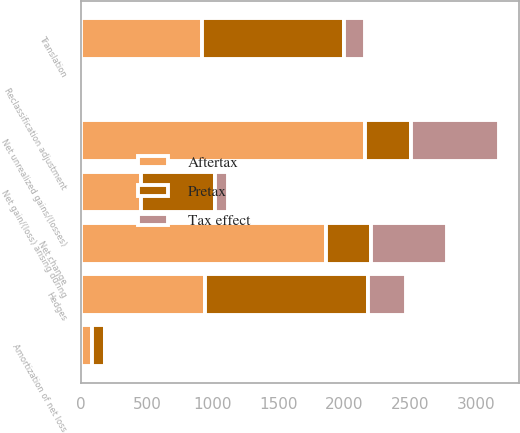Convert chart to OTSL. <chart><loc_0><loc_0><loc_500><loc_500><stacked_bar_chart><ecel><fcel>Net unrealized gains/(losses)<fcel>Reclassification adjustment<fcel>Net change<fcel>Translation<fcel>Hedges<fcel>Net gain/(loss) arising during<fcel>Amortization of net loss<nl><fcel>Pretax<fcel>348.5<fcel>18<fcel>348.5<fcel>1078<fcel>1236<fcel>558<fcel>103<nl><fcel>Tax effect<fcel>665<fcel>4<fcel>572<fcel>156<fcel>294<fcel>102<fcel>24<nl><fcel>Aftertax<fcel>2160<fcel>14<fcel>1858<fcel>922<fcel>942<fcel>456<fcel>79<nl></chart> 